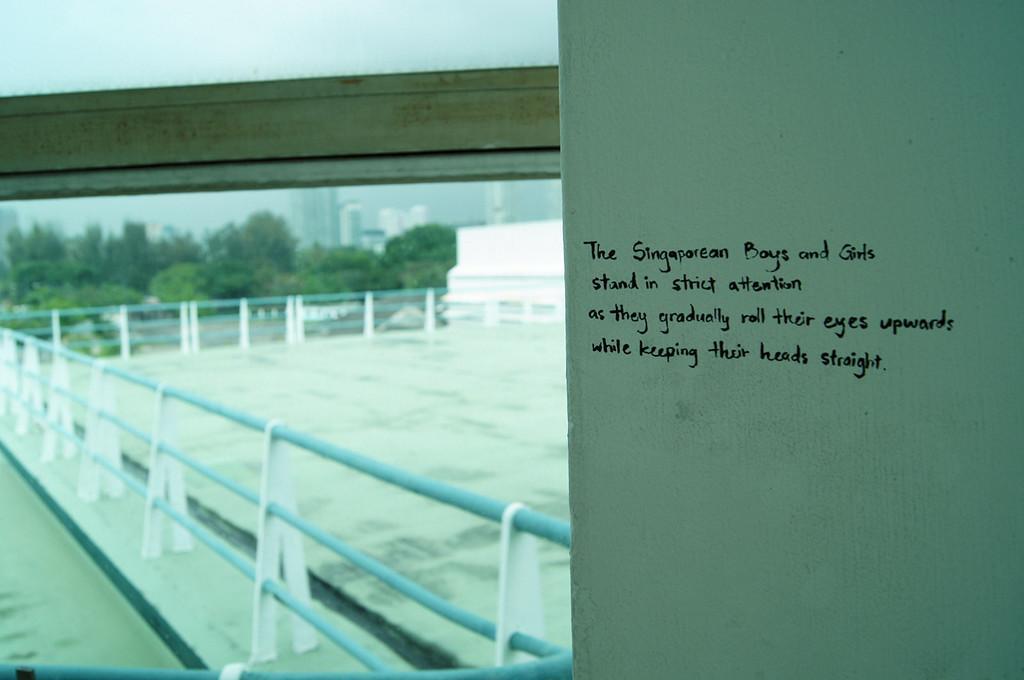How would you summarize this image in a sentence or two? Here we can see text written on a white platform. This is a fence. In the background we can see trees, buildings, and sky. 